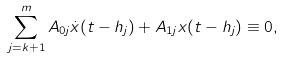<formula> <loc_0><loc_0><loc_500><loc_500>\sum _ { j = k + 1 } ^ { m } A _ { 0 j } \dot { x } ( t - h _ { j } ) + A _ { 1 j } x ( t - h _ { j } ) \equiv 0 ,</formula> 